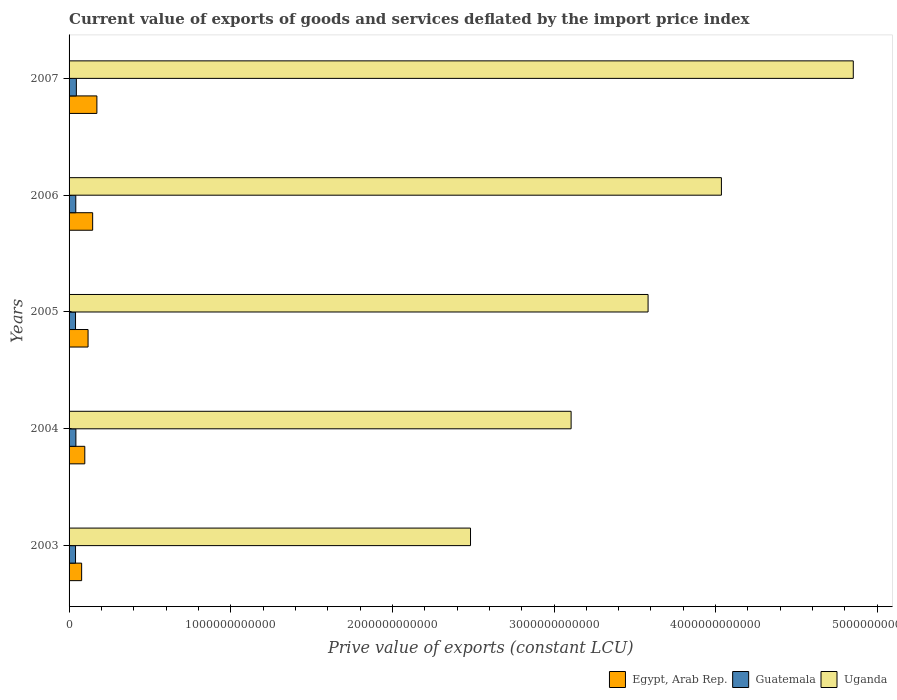Are the number of bars on each tick of the Y-axis equal?
Your answer should be very brief. Yes. How many bars are there on the 1st tick from the bottom?
Your answer should be compact. 3. What is the label of the 3rd group of bars from the top?
Make the answer very short. 2005. What is the prive value of exports in Egypt, Arab Rep. in 2004?
Your answer should be very brief. 9.73e+1. Across all years, what is the maximum prive value of exports in Egypt, Arab Rep.?
Keep it short and to the point. 1.72e+11. Across all years, what is the minimum prive value of exports in Uganda?
Provide a short and direct response. 2.48e+12. In which year was the prive value of exports in Guatemala maximum?
Offer a terse response. 2007. What is the total prive value of exports in Uganda in the graph?
Ensure brevity in your answer.  1.81e+13. What is the difference between the prive value of exports in Guatemala in 2003 and that in 2004?
Your response must be concise. -2.23e+09. What is the difference between the prive value of exports in Guatemala in 2004 and the prive value of exports in Egypt, Arab Rep. in 2007?
Give a very brief answer. -1.30e+11. What is the average prive value of exports in Guatemala per year?
Your response must be concise. 4.17e+1. In the year 2007, what is the difference between the prive value of exports in Guatemala and prive value of exports in Uganda?
Offer a very short reply. -4.81e+12. What is the ratio of the prive value of exports in Uganda in 2006 to that in 2007?
Ensure brevity in your answer.  0.83. What is the difference between the highest and the second highest prive value of exports in Guatemala?
Keep it short and to the point. 2.94e+09. What is the difference between the highest and the lowest prive value of exports in Guatemala?
Ensure brevity in your answer.  5.17e+09. In how many years, is the prive value of exports in Egypt, Arab Rep. greater than the average prive value of exports in Egypt, Arab Rep. taken over all years?
Your answer should be compact. 2. Is the sum of the prive value of exports in Guatemala in 2003 and 2005 greater than the maximum prive value of exports in Egypt, Arab Rep. across all years?
Give a very brief answer. No. What does the 3rd bar from the top in 2003 represents?
Offer a very short reply. Egypt, Arab Rep. What does the 2nd bar from the bottom in 2004 represents?
Offer a terse response. Guatemala. Are all the bars in the graph horizontal?
Make the answer very short. Yes. How many years are there in the graph?
Provide a succinct answer. 5. What is the difference between two consecutive major ticks on the X-axis?
Provide a short and direct response. 1.00e+12. Are the values on the major ticks of X-axis written in scientific E-notation?
Ensure brevity in your answer.  No. Does the graph contain any zero values?
Give a very brief answer. No. Where does the legend appear in the graph?
Provide a short and direct response. Bottom right. How many legend labels are there?
Provide a succinct answer. 3. How are the legend labels stacked?
Offer a terse response. Horizontal. What is the title of the graph?
Make the answer very short. Current value of exports of goods and services deflated by the import price index. Does "Small states" appear as one of the legend labels in the graph?
Your answer should be compact. No. What is the label or title of the X-axis?
Offer a terse response. Prive value of exports (constant LCU). What is the label or title of the Y-axis?
Offer a very short reply. Years. What is the Prive value of exports (constant LCU) in Egypt, Arab Rep. in 2003?
Give a very brief answer. 7.78e+1. What is the Prive value of exports (constant LCU) of Guatemala in 2003?
Provide a succinct answer. 4.00e+1. What is the Prive value of exports (constant LCU) in Uganda in 2003?
Offer a very short reply. 2.48e+12. What is the Prive value of exports (constant LCU) of Egypt, Arab Rep. in 2004?
Give a very brief answer. 9.73e+1. What is the Prive value of exports (constant LCU) in Guatemala in 2004?
Offer a very short reply. 4.22e+1. What is the Prive value of exports (constant LCU) of Uganda in 2004?
Offer a terse response. 3.11e+12. What is the Prive value of exports (constant LCU) in Egypt, Arab Rep. in 2005?
Make the answer very short. 1.18e+11. What is the Prive value of exports (constant LCU) of Guatemala in 2005?
Provide a succinct answer. 4.00e+1. What is the Prive value of exports (constant LCU) of Uganda in 2005?
Your answer should be very brief. 3.58e+12. What is the Prive value of exports (constant LCU) of Egypt, Arab Rep. in 2006?
Give a very brief answer. 1.46e+11. What is the Prive value of exports (constant LCU) of Guatemala in 2006?
Offer a very short reply. 4.15e+1. What is the Prive value of exports (constant LCU) of Uganda in 2006?
Provide a succinct answer. 4.04e+12. What is the Prive value of exports (constant LCU) in Egypt, Arab Rep. in 2007?
Your response must be concise. 1.72e+11. What is the Prive value of exports (constant LCU) of Guatemala in 2007?
Your answer should be very brief. 4.51e+1. What is the Prive value of exports (constant LCU) in Uganda in 2007?
Provide a short and direct response. 4.85e+12. Across all years, what is the maximum Prive value of exports (constant LCU) of Egypt, Arab Rep.?
Your answer should be compact. 1.72e+11. Across all years, what is the maximum Prive value of exports (constant LCU) of Guatemala?
Provide a succinct answer. 4.51e+1. Across all years, what is the maximum Prive value of exports (constant LCU) of Uganda?
Ensure brevity in your answer.  4.85e+12. Across all years, what is the minimum Prive value of exports (constant LCU) of Egypt, Arab Rep.?
Your answer should be compact. 7.78e+1. Across all years, what is the minimum Prive value of exports (constant LCU) in Guatemala?
Ensure brevity in your answer.  4.00e+1. Across all years, what is the minimum Prive value of exports (constant LCU) of Uganda?
Offer a terse response. 2.48e+12. What is the total Prive value of exports (constant LCU) in Egypt, Arab Rep. in the graph?
Your answer should be compact. 6.11e+11. What is the total Prive value of exports (constant LCU) of Guatemala in the graph?
Provide a short and direct response. 2.09e+11. What is the total Prive value of exports (constant LCU) in Uganda in the graph?
Offer a terse response. 1.81e+13. What is the difference between the Prive value of exports (constant LCU) in Egypt, Arab Rep. in 2003 and that in 2004?
Your answer should be very brief. -1.95e+1. What is the difference between the Prive value of exports (constant LCU) in Guatemala in 2003 and that in 2004?
Provide a short and direct response. -2.23e+09. What is the difference between the Prive value of exports (constant LCU) of Uganda in 2003 and that in 2004?
Keep it short and to the point. -6.22e+11. What is the difference between the Prive value of exports (constant LCU) in Egypt, Arab Rep. in 2003 and that in 2005?
Give a very brief answer. -3.98e+1. What is the difference between the Prive value of exports (constant LCU) in Guatemala in 2003 and that in 2005?
Offer a terse response. -5.38e+07. What is the difference between the Prive value of exports (constant LCU) in Uganda in 2003 and that in 2005?
Your answer should be compact. -1.10e+12. What is the difference between the Prive value of exports (constant LCU) in Egypt, Arab Rep. in 2003 and that in 2006?
Offer a terse response. -6.81e+1. What is the difference between the Prive value of exports (constant LCU) in Guatemala in 2003 and that in 2006?
Keep it short and to the point. -1.52e+09. What is the difference between the Prive value of exports (constant LCU) in Uganda in 2003 and that in 2006?
Your answer should be compact. -1.55e+12. What is the difference between the Prive value of exports (constant LCU) in Egypt, Arab Rep. in 2003 and that in 2007?
Give a very brief answer. -9.43e+1. What is the difference between the Prive value of exports (constant LCU) of Guatemala in 2003 and that in 2007?
Your response must be concise. -5.17e+09. What is the difference between the Prive value of exports (constant LCU) in Uganda in 2003 and that in 2007?
Offer a terse response. -2.37e+12. What is the difference between the Prive value of exports (constant LCU) in Egypt, Arab Rep. in 2004 and that in 2005?
Your answer should be very brief. -2.02e+1. What is the difference between the Prive value of exports (constant LCU) of Guatemala in 2004 and that in 2005?
Your answer should be very brief. 2.17e+09. What is the difference between the Prive value of exports (constant LCU) of Uganda in 2004 and that in 2005?
Your answer should be very brief. -4.76e+11. What is the difference between the Prive value of exports (constant LCU) in Egypt, Arab Rep. in 2004 and that in 2006?
Your response must be concise. -4.86e+1. What is the difference between the Prive value of exports (constant LCU) in Guatemala in 2004 and that in 2006?
Offer a terse response. 7.06e+08. What is the difference between the Prive value of exports (constant LCU) of Uganda in 2004 and that in 2006?
Provide a succinct answer. -9.30e+11. What is the difference between the Prive value of exports (constant LCU) in Egypt, Arab Rep. in 2004 and that in 2007?
Provide a short and direct response. -7.47e+1. What is the difference between the Prive value of exports (constant LCU) of Guatemala in 2004 and that in 2007?
Provide a short and direct response. -2.94e+09. What is the difference between the Prive value of exports (constant LCU) in Uganda in 2004 and that in 2007?
Ensure brevity in your answer.  -1.75e+12. What is the difference between the Prive value of exports (constant LCU) in Egypt, Arab Rep. in 2005 and that in 2006?
Offer a terse response. -2.84e+1. What is the difference between the Prive value of exports (constant LCU) in Guatemala in 2005 and that in 2006?
Make the answer very short. -1.47e+09. What is the difference between the Prive value of exports (constant LCU) of Uganda in 2005 and that in 2006?
Keep it short and to the point. -4.54e+11. What is the difference between the Prive value of exports (constant LCU) of Egypt, Arab Rep. in 2005 and that in 2007?
Give a very brief answer. -5.45e+1. What is the difference between the Prive value of exports (constant LCU) in Guatemala in 2005 and that in 2007?
Give a very brief answer. -5.12e+09. What is the difference between the Prive value of exports (constant LCU) of Uganda in 2005 and that in 2007?
Make the answer very short. -1.27e+12. What is the difference between the Prive value of exports (constant LCU) in Egypt, Arab Rep. in 2006 and that in 2007?
Provide a short and direct response. -2.61e+1. What is the difference between the Prive value of exports (constant LCU) in Guatemala in 2006 and that in 2007?
Keep it short and to the point. -3.65e+09. What is the difference between the Prive value of exports (constant LCU) in Uganda in 2006 and that in 2007?
Provide a short and direct response. -8.16e+11. What is the difference between the Prive value of exports (constant LCU) in Egypt, Arab Rep. in 2003 and the Prive value of exports (constant LCU) in Guatemala in 2004?
Your response must be concise. 3.56e+1. What is the difference between the Prive value of exports (constant LCU) of Egypt, Arab Rep. in 2003 and the Prive value of exports (constant LCU) of Uganda in 2004?
Provide a succinct answer. -3.03e+12. What is the difference between the Prive value of exports (constant LCU) of Guatemala in 2003 and the Prive value of exports (constant LCU) of Uganda in 2004?
Give a very brief answer. -3.07e+12. What is the difference between the Prive value of exports (constant LCU) of Egypt, Arab Rep. in 2003 and the Prive value of exports (constant LCU) of Guatemala in 2005?
Offer a very short reply. 3.78e+1. What is the difference between the Prive value of exports (constant LCU) of Egypt, Arab Rep. in 2003 and the Prive value of exports (constant LCU) of Uganda in 2005?
Ensure brevity in your answer.  -3.50e+12. What is the difference between the Prive value of exports (constant LCU) of Guatemala in 2003 and the Prive value of exports (constant LCU) of Uganda in 2005?
Provide a short and direct response. -3.54e+12. What is the difference between the Prive value of exports (constant LCU) of Egypt, Arab Rep. in 2003 and the Prive value of exports (constant LCU) of Guatemala in 2006?
Offer a very short reply. 3.63e+1. What is the difference between the Prive value of exports (constant LCU) in Egypt, Arab Rep. in 2003 and the Prive value of exports (constant LCU) in Uganda in 2006?
Offer a very short reply. -3.96e+12. What is the difference between the Prive value of exports (constant LCU) in Guatemala in 2003 and the Prive value of exports (constant LCU) in Uganda in 2006?
Offer a terse response. -4.00e+12. What is the difference between the Prive value of exports (constant LCU) of Egypt, Arab Rep. in 2003 and the Prive value of exports (constant LCU) of Guatemala in 2007?
Provide a short and direct response. 3.26e+1. What is the difference between the Prive value of exports (constant LCU) of Egypt, Arab Rep. in 2003 and the Prive value of exports (constant LCU) of Uganda in 2007?
Keep it short and to the point. -4.77e+12. What is the difference between the Prive value of exports (constant LCU) in Guatemala in 2003 and the Prive value of exports (constant LCU) in Uganda in 2007?
Your answer should be very brief. -4.81e+12. What is the difference between the Prive value of exports (constant LCU) in Egypt, Arab Rep. in 2004 and the Prive value of exports (constant LCU) in Guatemala in 2005?
Offer a very short reply. 5.73e+1. What is the difference between the Prive value of exports (constant LCU) in Egypt, Arab Rep. in 2004 and the Prive value of exports (constant LCU) in Uganda in 2005?
Give a very brief answer. -3.48e+12. What is the difference between the Prive value of exports (constant LCU) in Guatemala in 2004 and the Prive value of exports (constant LCU) in Uganda in 2005?
Your response must be concise. -3.54e+12. What is the difference between the Prive value of exports (constant LCU) of Egypt, Arab Rep. in 2004 and the Prive value of exports (constant LCU) of Guatemala in 2006?
Keep it short and to the point. 5.58e+1. What is the difference between the Prive value of exports (constant LCU) of Egypt, Arab Rep. in 2004 and the Prive value of exports (constant LCU) of Uganda in 2006?
Your answer should be very brief. -3.94e+12. What is the difference between the Prive value of exports (constant LCU) of Guatemala in 2004 and the Prive value of exports (constant LCU) of Uganda in 2006?
Offer a very short reply. -3.99e+12. What is the difference between the Prive value of exports (constant LCU) in Egypt, Arab Rep. in 2004 and the Prive value of exports (constant LCU) in Guatemala in 2007?
Give a very brief answer. 5.22e+1. What is the difference between the Prive value of exports (constant LCU) in Egypt, Arab Rep. in 2004 and the Prive value of exports (constant LCU) in Uganda in 2007?
Make the answer very short. -4.75e+12. What is the difference between the Prive value of exports (constant LCU) in Guatemala in 2004 and the Prive value of exports (constant LCU) in Uganda in 2007?
Provide a short and direct response. -4.81e+12. What is the difference between the Prive value of exports (constant LCU) of Egypt, Arab Rep. in 2005 and the Prive value of exports (constant LCU) of Guatemala in 2006?
Make the answer very short. 7.60e+1. What is the difference between the Prive value of exports (constant LCU) of Egypt, Arab Rep. in 2005 and the Prive value of exports (constant LCU) of Uganda in 2006?
Keep it short and to the point. -3.92e+12. What is the difference between the Prive value of exports (constant LCU) in Guatemala in 2005 and the Prive value of exports (constant LCU) in Uganda in 2006?
Provide a succinct answer. -4.00e+12. What is the difference between the Prive value of exports (constant LCU) in Egypt, Arab Rep. in 2005 and the Prive value of exports (constant LCU) in Guatemala in 2007?
Offer a terse response. 7.24e+1. What is the difference between the Prive value of exports (constant LCU) of Egypt, Arab Rep. in 2005 and the Prive value of exports (constant LCU) of Uganda in 2007?
Your response must be concise. -4.73e+12. What is the difference between the Prive value of exports (constant LCU) of Guatemala in 2005 and the Prive value of exports (constant LCU) of Uganda in 2007?
Offer a very short reply. -4.81e+12. What is the difference between the Prive value of exports (constant LCU) in Egypt, Arab Rep. in 2006 and the Prive value of exports (constant LCU) in Guatemala in 2007?
Ensure brevity in your answer.  1.01e+11. What is the difference between the Prive value of exports (constant LCU) of Egypt, Arab Rep. in 2006 and the Prive value of exports (constant LCU) of Uganda in 2007?
Provide a succinct answer. -4.71e+12. What is the difference between the Prive value of exports (constant LCU) in Guatemala in 2006 and the Prive value of exports (constant LCU) in Uganda in 2007?
Provide a succinct answer. -4.81e+12. What is the average Prive value of exports (constant LCU) of Egypt, Arab Rep. per year?
Your answer should be compact. 1.22e+11. What is the average Prive value of exports (constant LCU) in Guatemala per year?
Offer a terse response. 4.17e+1. What is the average Prive value of exports (constant LCU) of Uganda per year?
Make the answer very short. 3.61e+12. In the year 2003, what is the difference between the Prive value of exports (constant LCU) of Egypt, Arab Rep. and Prive value of exports (constant LCU) of Guatemala?
Ensure brevity in your answer.  3.78e+1. In the year 2003, what is the difference between the Prive value of exports (constant LCU) in Egypt, Arab Rep. and Prive value of exports (constant LCU) in Uganda?
Provide a succinct answer. -2.41e+12. In the year 2003, what is the difference between the Prive value of exports (constant LCU) of Guatemala and Prive value of exports (constant LCU) of Uganda?
Ensure brevity in your answer.  -2.44e+12. In the year 2004, what is the difference between the Prive value of exports (constant LCU) in Egypt, Arab Rep. and Prive value of exports (constant LCU) in Guatemala?
Give a very brief answer. 5.51e+1. In the year 2004, what is the difference between the Prive value of exports (constant LCU) in Egypt, Arab Rep. and Prive value of exports (constant LCU) in Uganda?
Ensure brevity in your answer.  -3.01e+12. In the year 2004, what is the difference between the Prive value of exports (constant LCU) of Guatemala and Prive value of exports (constant LCU) of Uganda?
Keep it short and to the point. -3.06e+12. In the year 2005, what is the difference between the Prive value of exports (constant LCU) of Egypt, Arab Rep. and Prive value of exports (constant LCU) of Guatemala?
Make the answer very short. 7.75e+1. In the year 2005, what is the difference between the Prive value of exports (constant LCU) of Egypt, Arab Rep. and Prive value of exports (constant LCU) of Uganda?
Ensure brevity in your answer.  -3.46e+12. In the year 2005, what is the difference between the Prive value of exports (constant LCU) of Guatemala and Prive value of exports (constant LCU) of Uganda?
Offer a very short reply. -3.54e+12. In the year 2006, what is the difference between the Prive value of exports (constant LCU) in Egypt, Arab Rep. and Prive value of exports (constant LCU) in Guatemala?
Your answer should be very brief. 1.04e+11. In the year 2006, what is the difference between the Prive value of exports (constant LCU) in Egypt, Arab Rep. and Prive value of exports (constant LCU) in Uganda?
Keep it short and to the point. -3.89e+12. In the year 2006, what is the difference between the Prive value of exports (constant LCU) in Guatemala and Prive value of exports (constant LCU) in Uganda?
Your answer should be very brief. -3.99e+12. In the year 2007, what is the difference between the Prive value of exports (constant LCU) of Egypt, Arab Rep. and Prive value of exports (constant LCU) of Guatemala?
Offer a terse response. 1.27e+11. In the year 2007, what is the difference between the Prive value of exports (constant LCU) of Egypt, Arab Rep. and Prive value of exports (constant LCU) of Uganda?
Give a very brief answer. -4.68e+12. In the year 2007, what is the difference between the Prive value of exports (constant LCU) of Guatemala and Prive value of exports (constant LCU) of Uganda?
Provide a succinct answer. -4.81e+12. What is the ratio of the Prive value of exports (constant LCU) of Egypt, Arab Rep. in 2003 to that in 2004?
Make the answer very short. 0.8. What is the ratio of the Prive value of exports (constant LCU) in Guatemala in 2003 to that in 2004?
Your answer should be compact. 0.95. What is the ratio of the Prive value of exports (constant LCU) of Uganda in 2003 to that in 2004?
Offer a very short reply. 0.8. What is the ratio of the Prive value of exports (constant LCU) of Egypt, Arab Rep. in 2003 to that in 2005?
Your response must be concise. 0.66. What is the ratio of the Prive value of exports (constant LCU) of Uganda in 2003 to that in 2005?
Ensure brevity in your answer.  0.69. What is the ratio of the Prive value of exports (constant LCU) of Egypt, Arab Rep. in 2003 to that in 2006?
Your answer should be compact. 0.53. What is the ratio of the Prive value of exports (constant LCU) in Guatemala in 2003 to that in 2006?
Your response must be concise. 0.96. What is the ratio of the Prive value of exports (constant LCU) in Uganda in 2003 to that in 2006?
Offer a very short reply. 0.62. What is the ratio of the Prive value of exports (constant LCU) of Egypt, Arab Rep. in 2003 to that in 2007?
Your answer should be compact. 0.45. What is the ratio of the Prive value of exports (constant LCU) of Guatemala in 2003 to that in 2007?
Keep it short and to the point. 0.89. What is the ratio of the Prive value of exports (constant LCU) of Uganda in 2003 to that in 2007?
Offer a terse response. 0.51. What is the ratio of the Prive value of exports (constant LCU) of Egypt, Arab Rep. in 2004 to that in 2005?
Offer a terse response. 0.83. What is the ratio of the Prive value of exports (constant LCU) of Guatemala in 2004 to that in 2005?
Ensure brevity in your answer.  1.05. What is the ratio of the Prive value of exports (constant LCU) of Uganda in 2004 to that in 2005?
Keep it short and to the point. 0.87. What is the ratio of the Prive value of exports (constant LCU) in Egypt, Arab Rep. in 2004 to that in 2006?
Ensure brevity in your answer.  0.67. What is the ratio of the Prive value of exports (constant LCU) of Guatemala in 2004 to that in 2006?
Make the answer very short. 1.02. What is the ratio of the Prive value of exports (constant LCU) in Uganda in 2004 to that in 2006?
Make the answer very short. 0.77. What is the ratio of the Prive value of exports (constant LCU) of Egypt, Arab Rep. in 2004 to that in 2007?
Provide a short and direct response. 0.57. What is the ratio of the Prive value of exports (constant LCU) of Guatemala in 2004 to that in 2007?
Offer a very short reply. 0.93. What is the ratio of the Prive value of exports (constant LCU) in Uganda in 2004 to that in 2007?
Make the answer very short. 0.64. What is the ratio of the Prive value of exports (constant LCU) in Egypt, Arab Rep. in 2005 to that in 2006?
Provide a succinct answer. 0.81. What is the ratio of the Prive value of exports (constant LCU) in Guatemala in 2005 to that in 2006?
Make the answer very short. 0.96. What is the ratio of the Prive value of exports (constant LCU) of Uganda in 2005 to that in 2006?
Your answer should be very brief. 0.89. What is the ratio of the Prive value of exports (constant LCU) in Egypt, Arab Rep. in 2005 to that in 2007?
Give a very brief answer. 0.68. What is the ratio of the Prive value of exports (constant LCU) of Guatemala in 2005 to that in 2007?
Keep it short and to the point. 0.89. What is the ratio of the Prive value of exports (constant LCU) of Uganda in 2005 to that in 2007?
Offer a terse response. 0.74. What is the ratio of the Prive value of exports (constant LCU) of Egypt, Arab Rep. in 2006 to that in 2007?
Your response must be concise. 0.85. What is the ratio of the Prive value of exports (constant LCU) in Guatemala in 2006 to that in 2007?
Provide a succinct answer. 0.92. What is the ratio of the Prive value of exports (constant LCU) of Uganda in 2006 to that in 2007?
Your answer should be compact. 0.83. What is the difference between the highest and the second highest Prive value of exports (constant LCU) in Egypt, Arab Rep.?
Offer a terse response. 2.61e+1. What is the difference between the highest and the second highest Prive value of exports (constant LCU) of Guatemala?
Offer a terse response. 2.94e+09. What is the difference between the highest and the second highest Prive value of exports (constant LCU) in Uganda?
Offer a very short reply. 8.16e+11. What is the difference between the highest and the lowest Prive value of exports (constant LCU) of Egypt, Arab Rep.?
Make the answer very short. 9.43e+1. What is the difference between the highest and the lowest Prive value of exports (constant LCU) in Guatemala?
Your answer should be very brief. 5.17e+09. What is the difference between the highest and the lowest Prive value of exports (constant LCU) in Uganda?
Give a very brief answer. 2.37e+12. 